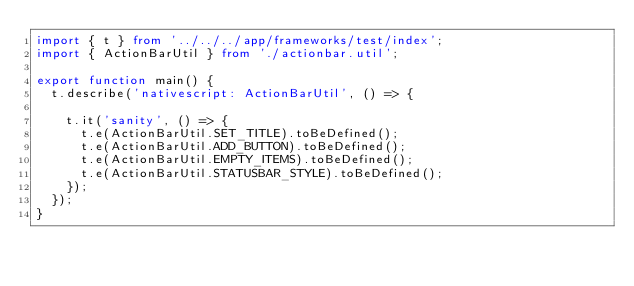<code> <loc_0><loc_0><loc_500><loc_500><_TypeScript_>import { t } from '../../../app/frameworks/test/index';
import { ActionBarUtil } from './actionbar.util';

export function main() {
  t.describe('nativescript: ActionBarUtil', () => {

    t.it('sanity', () => {
      t.e(ActionBarUtil.SET_TITLE).toBeDefined();
      t.e(ActionBarUtil.ADD_BUTTON).toBeDefined();
      t.e(ActionBarUtil.EMPTY_ITEMS).toBeDefined();
      t.e(ActionBarUtil.STATUSBAR_STYLE).toBeDefined();
    });
  });
}
</code> 